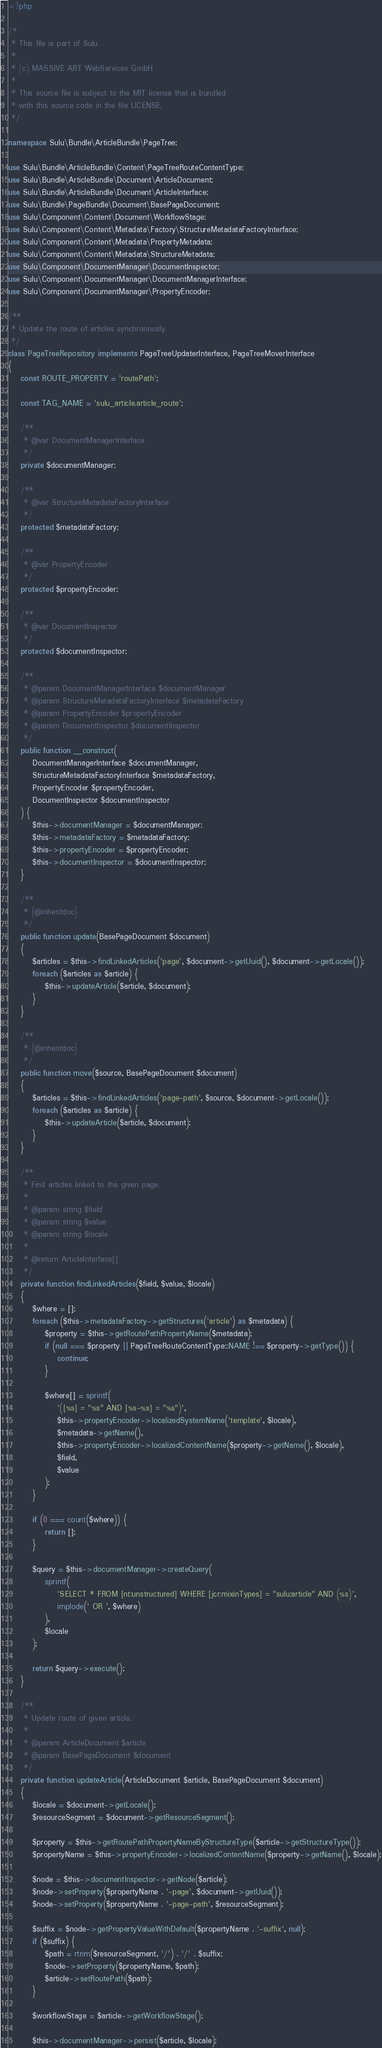Convert code to text. <code><loc_0><loc_0><loc_500><loc_500><_PHP_><?php

/*
 * This file is part of Sulu.
 *
 * (c) MASSIVE ART WebServices GmbH
 *
 * This source file is subject to the MIT license that is bundled
 * with this source code in the file LICENSE.
 */

namespace Sulu\Bundle\ArticleBundle\PageTree;

use Sulu\Bundle\ArticleBundle\Content\PageTreeRouteContentType;
use Sulu\Bundle\ArticleBundle\Document\ArticleDocument;
use Sulu\Bundle\ArticleBundle\Document\ArticleInterface;
use Sulu\Bundle\PageBundle\Document\BasePageDocument;
use Sulu\Component\Content\Document\WorkflowStage;
use Sulu\Component\Content\Metadata\Factory\StructureMetadataFactoryInterface;
use Sulu\Component\Content\Metadata\PropertyMetadata;
use Sulu\Component\Content\Metadata\StructureMetadata;
use Sulu\Component\DocumentManager\DocumentInspector;
use Sulu\Component\DocumentManager\DocumentManagerInterface;
use Sulu\Component\DocumentManager\PropertyEncoder;

/**
 * Update the route of articles synchronously.
 */
class PageTreeRepository implements PageTreeUpdaterInterface, PageTreeMoverInterface
{
    const ROUTE_PROPERTY = 'routePath';

    const TAG_NAME = 'sulu_article.article_route';

    /**
     * @var DocumentManagerInterface
     */
    private $documentManager;

    /**
     * @var StructureMetadataFactoryInterface
     */
    protected $metadataFactory;

    /**
     * @var PropertyEncoder
     */
    protected $propertyEncoder;

    /**
     * @var DocumentInspector
     */
    protected $documentInspector;

    /**
     * @param DocumentManagerInterface $documentManager
     * @param StructureMetadataFactoryInterface $metadataFactory
     * @param PropertyEncoder $propertyEncoder
     * @param DocumentInspector $documentInspector
     */
    public function __construct(
        DocumentManagerInterface $documentManager,
        StructureMetadataFactoryInterface $metadataFactory,
        PropertyEncoder $propertyEncoder,
        DocumentInspector $documentInspector
    ) {
        $this->documentManager = $documentManager;
        $this->metadataFactory = $metadataFactory;
        $this->propertyEncoder = $propertyEncoder;
        $this->documentInspector = $documentInspector;
    }

    /**
     * {@inheritdoc}
     */
    public function update(BasePageDocument $document)
    {
        $articles = $this->findLinkedArticles('page', $document->getUuid(), $document->getLocale());
        foreach ($articles as $article) {
            $this->updateArticle($article, $document);
        }
    }

    /**
     * {@inheritdoc}
     */
    public function move($source, BasePageDocument $document)
    {
        $articles = $this->findLinkedArticles('page-path', $source, $document->getLocale());
        foreach ($articles as $article) {
            $this->updateArticle($article, $document);
        }
    }

    /**
     * Find articles linked to the given page.
     *
     * @param string $field
     * @param string $value
     * @param string $locale
     *
     * @return ArticleInterface[]
     */
    private function findLinkedArticles($field, $value, $locale)
    {
        $where = [];
        foreach ($this->metadataFactory->getStructures('article') as $metadata) {
            $property = $this->getRoutePathPropertyName($metadata);
            if (null === $property || PageTreeRouteContentType::NAME !== $property->getType()) {
                continue;
            }

            $where[] = sprintf(
                '([%s] = "%s" AND [%s-%s] = "%s")',
                $this->propertyEncoder->localizedSystemName('template', $locale),
                $metadata->getName(),
                $this->propertyEncoder->localizedContentName($property->getName(), $locale),
                $field,
                $value
            );
        }

        if (0 === count($where)) {
            return [];
        }

        $query = $this->documentManager->createQuery(
            sprintf(
                'SELECT * FROM [nt:unstructured] WHERE [jcr:mixinTypes] = "sulu:article" AND (%s)',
                implode(' OR ', $where)
            ),
            $locale
        );

        return $query->execute();
    }

    /**
     * Update route of given article.
     *
     * @param ArticleDocument $article
     * @param BasePageDocument $document
     */
    private function updateArticle(ArticleDocument $article, BasePageDocument $document)
    {
        $locale = $document->getLocale();
        $resourceSegment = $document->getResourceSegment();

        $property = $this->getRoutePathPropertyNameByStructureType($article->getStructureType());
        $propertyName = $this->propertyEncoder->localizedContentName($property->getName(), $locale);

        $node = $this->documentInspector->getNode($article);
        $node->setProperty($propertyName . '-page', $document->getUuid());
        $node->setProperty($propertyName . '-page-path', $resourceSegment);

        $suffix = $node->getPropertyValueWithDefault($propertyName . '-suffix', null);
        if ($suffix) {
            $path = rtrim($resourceSegment, '/') . '/' . $suffix;
            $node->setProperty($propertyName, $path);
            $article->setRoutePath($path);
        }

        $workflowStage = $article->getWorkflowStage();

        $this->documentManager->persist($article, $locale);</code> 